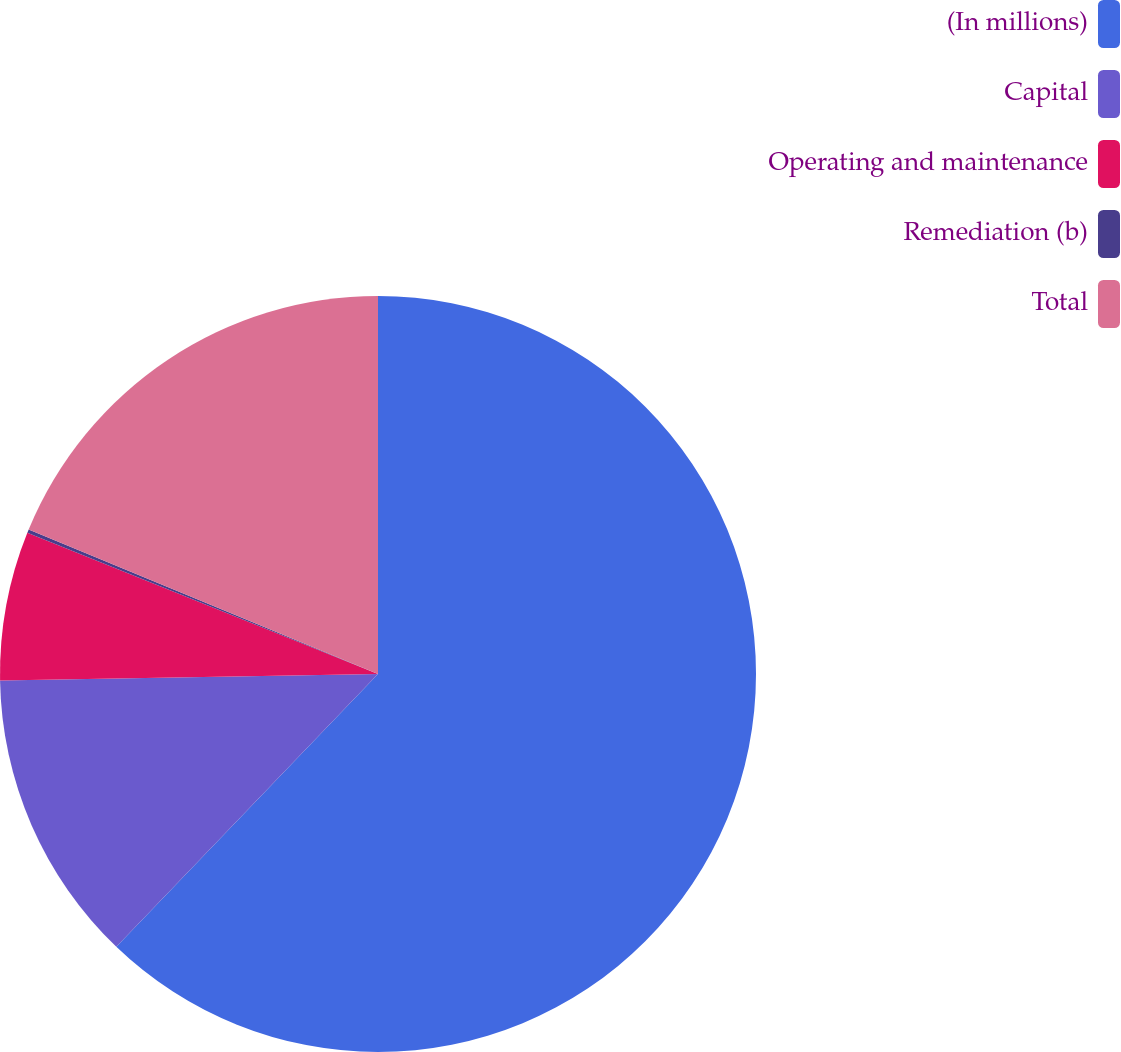Convert chart. <chart><loc_0><loc_0><loc_500><loc_500><pie_chart><fcel>(In millions)<fcel>Capital<fcel>Operating and maintenance<fcel>Remediation (b)<fcel>Total<nl><fcel>62.17%<fcel>12.56%<fcel>6.36%<fcel>0.15%<fcel>18.76%<nl></chart> 